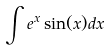Convert formula to latex. <formula><loc_0><loc_0><loc_500><loc_500>\int e ^ { x } \sin ( x ) d x</formula> 